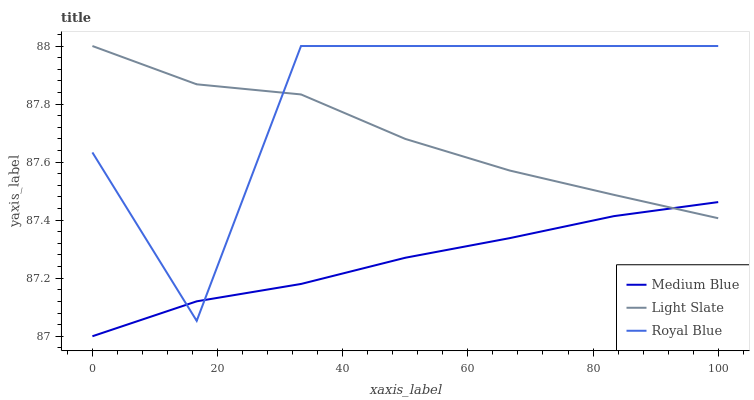Does Medium Blue have the minimum area under the curve?
Answer yes or no. Yes. Does Royal Blue have the maximum area under the curve?
Answer yes or no. Yes. Does Royal Blue have the minimum area under the curve?
Answer yes or no. No. Does Medium Blue have the maximum area under the curve?
Answer yes or no. No. Is Medium Blue the smoothest?
Answer yes or no. Yes. Is Royal Blue the roughest?
Answer yes or no. Yes. Is Royal Blue the smoothest?
Answer yes or no. No. Is Medium Blue the roughest?
Answer yes or no. No. Does Medium Blue have the lowest value?
Answer yes or no. Yes. Does Royal Blue have the lowest value?
Answer yes or no. No. Does Royal Blue have the highest value?
Answer yes or no. Yes. Does Medium Blue have the highest value?
Answer yes or no. No. Does Medium Blue intersect Light Slate?
Answer yes or no. Yes. Is Medium Blue less than Light Slate?
Answer yes or no. No. Is Medium Blue greater than Light Slate?
Answer yes or no. No. 